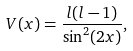<formula> <loc_0><loc_0><loc_500><loc_500>V ( x ) = \frac { l ( l - 1 ) } { \sin ^ { 2 } ( 2 x ) } ,</formula> 